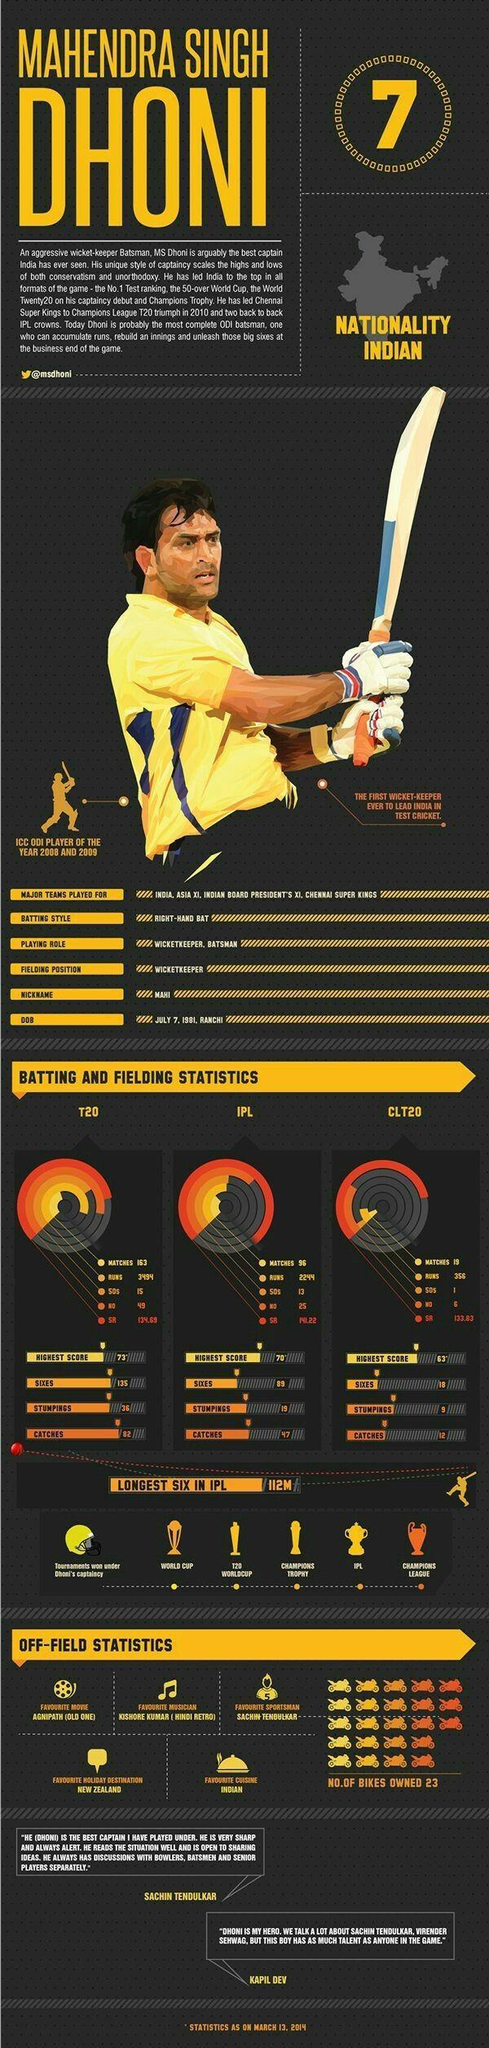How many sixes were played by M.S. Dhoni in IPL matches as of March 13, 2014?
Answer the question with a short phrase. 89 What is the number of 50s scored by M.S. Dhoni in CLT20 tournament as of March 13, 2014? 1 What is the highest score of M.S. Dhoni in IPL as of March 13, 2014? 70* What is the highest score of M.S. Dhoni in T20 matches as of March 13, 2014? 73* What is the strike rate of M.S. Dhoni in IPL games as of March 13, 2014? 141.22 What is the number of catches taken by M.S. Dhoni in CLT20 matches as of March 13, 2014? 12 How many IPL matches were played by M.S. Dhoni as of March 13, 2014? 96 What is the strike rate of M.S. Dhoni in T20 matches as of March 13, 2014? 134.69 What is the number of catches taken by M.S. Dhoni in T20 matches as of March 13, 2014? 82 What is the total number of runs scored by M.S. Dhoni in IPL games as of March 13, 2014? 2244 